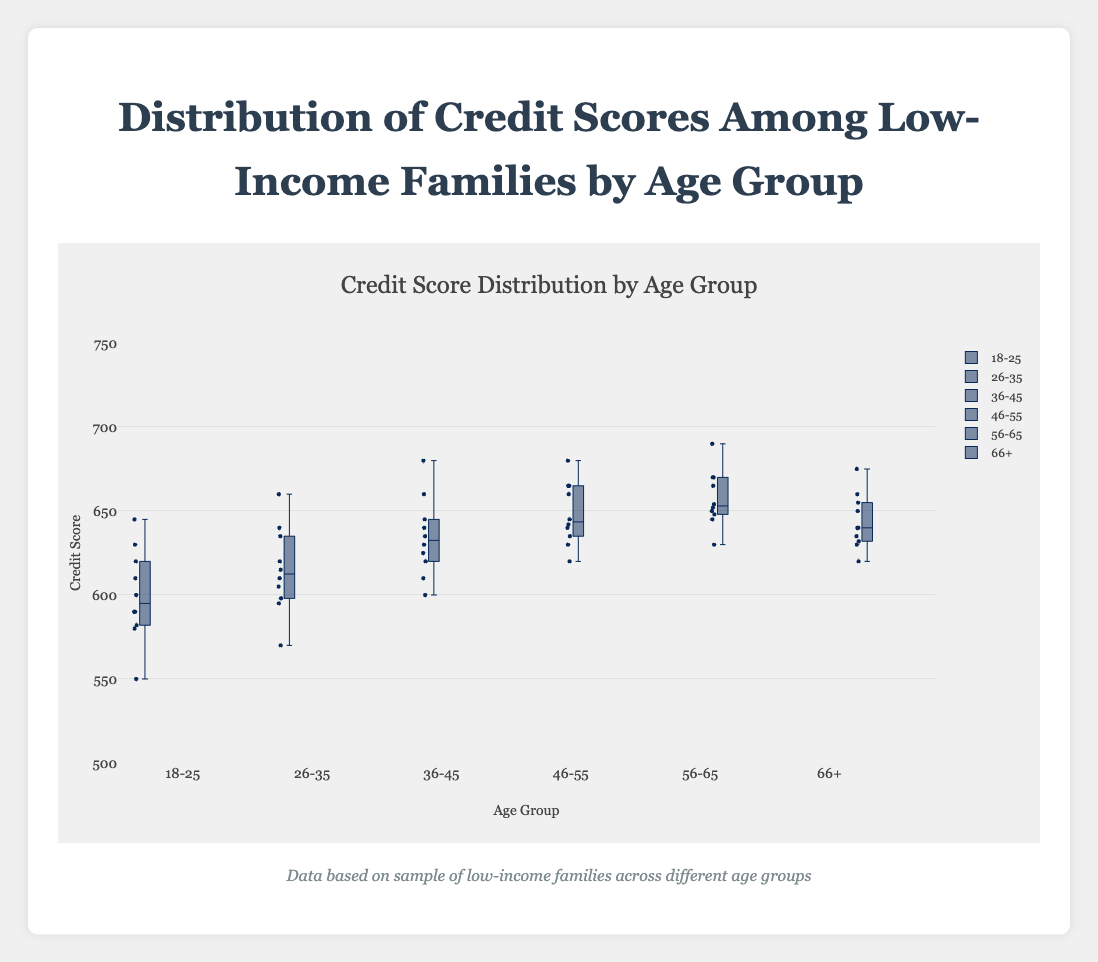What is the title of the figure? The title of the figure is usually positioned at the top, typically in larger, bold font.
Answer: Distribution of Credit Scores Among Low-Income Families by Age Group What are the age groups shown in the figure? The age groups are displayed along the x-axis and signify different boxes in the box plot. You can read them directly from the x-axis labels.
Answer: 18-25, 26-35, 36-45, 46-55, 56-65, 66+ Which age group has the highest median credit score? The median of each age group can be identified by the line inside each box. The highest line indicates the highest median score.
Answer: 56-65 Which age group has the most spread-out credit scores? The spread of each age group is demonstrated by the range between the minimum and maximum values (whiskers). The group with the longest whiskers has the most spread-out scores.
Answer: 18-25 Which age group has the smallest interquartile range (IQR)? The IQR is the distance between the first (bottom of box) and third quartile (top of box). The box with the shortest height shows the smallest IQR.
Answer: 56-65 How many credit scores are there in the age group 26-35? The number of individual points can be approximated by counting the plotted points within the box plot for the 26-35 age group.
Answer: 10 Are there any outliers in the age group 46-55? Outliers are usually represented by points outside the whiskers of the box plot. Check if there are any such points for the age group 46-55.
Answer: No What is the range of credit scores in the age group 36-45? The range is the difference between the maximum and minimum values within the whiskers of the box plot for the group 36-45.
Answer: 80 (680 - 600) Which age group appears to have the most consistent credit scores, and how can you tell? The consistency of credit scores can be judged by looking at the compactness of the box and shorter whiskers. The age group with the smallest IQR and range would be the most consistent.
Answer: 56-65 